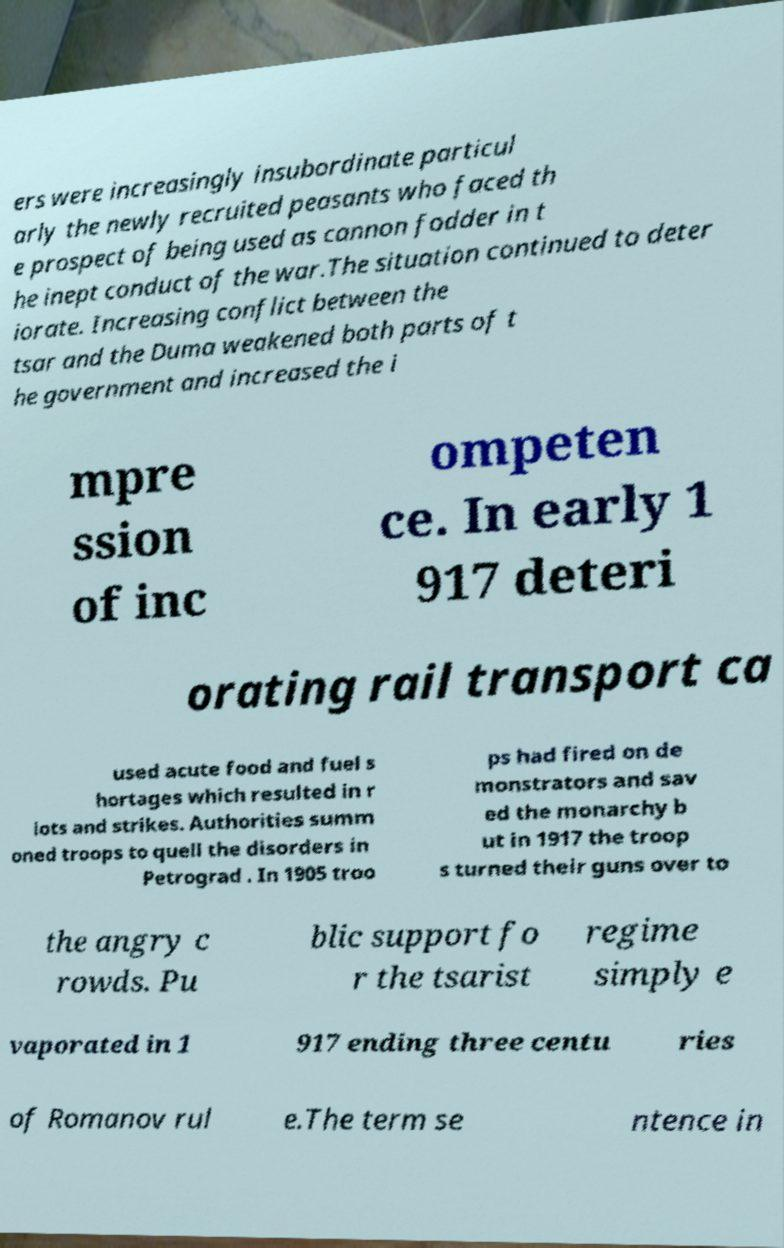Could you extract and type out the text from this image? ers were increasingly insubordinate particul arly the newly recruited peasants who faced th e prospect of being used as cannon fodder in t he inept conduct of the war.The situation continued to deter iorate. Increasing conflict between the tsar and the Duma weakened both parts of t he government and increased the i mpre ssion of inc ompeten ce. In early 1 917 deteri orating rail transport ca used acute food and fuel s hortages which resulted in r iots and strikes. Authorities summ oned troops to quell the disorders in Petrograd . In 1905 troo ps had fired on de monstrators and sav ed the monarchy b ut in 1917 the troop s turned their guns over to the angry c rowds. Pu blic support fo r the tsarist regime simply e vaporated in 1 917 ending three centu ries of Romanov rul e.The term se ntence in 